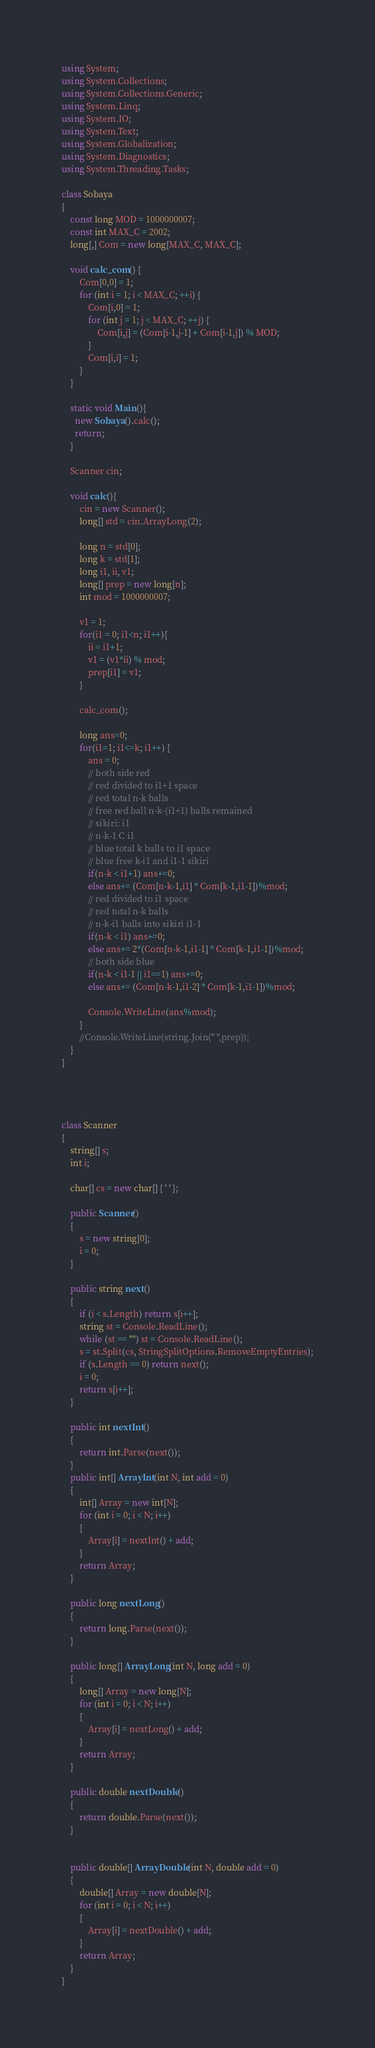Convert code to text. <code><loc_0><loc_0><loc_500><loc_500><_C#_>using System;
using System.Collections;
using System.Collections.Generic;
using System.Linq;
using System.IO;
using System.Text;
using System.Globalization;
using System.Diagnostics;
using System.Threading.Tasks;

class Sobaya
{
    const long MOD = 1000000007;
    const int MAX_C = 2002;
    long[,] Com = new long[MAX_C, MAX_C];
    
    void calc_com() {
        Com[0,0] = 1;
        for (int i = 1; i < MAX_C; ++i) {
            Com[i,0] = 1;
            for (int j = 1; j < MAX_C; ++j) {
                Com[i,j] = (Com[i-1,j-1] + Com[i-1,j]) % MOD;
            }
            Com[i,i] = 1;
        }
    }
    
    static void Main(){
      new Sobaya().calc();
      return;
    }
      
    Scanner cin;
    
    void calc(){
        cin = new Scanner();
        long[] std = cin.ArrayLong(2);
        
        long n = std[0];
        long k = std[1];
        long i1, ii, v1;
        long[] prep = new long[n];
        int mod = 1000000007;
        
        v1 = 1;
        for(i1 = 0; i1<n; i1++){
            ii = i1+1;
            v1 = (v1*ii) % mod;
            prep[i1] = v1;
        }
        
        calc_com();
        
        long ans=0;
        for(i1=1; i1<=k; i1++) {
            ans = 0;
            // both side red
            // red divided to i1+1 space
            // red total n-k balls
            // free red ball n-k-(i1+1) balls remained
            // sikiri: i1
            // n-k-1 C i1
            // blue total k balls to i1 space
            // blue free k-i1 and i1-1 sikiri
            if(n-k < i1+1) ans+=0;
            else ans+= (Com[n-k-1,i1] * Com[k-1,i1-1])%mod;
            // red divided to i1 space
            // red total n-k balls
            // n-k-i1 balls into sikiri i1-1
            if(n-k < i1) ans+=0;
            else ans+= 2*(Com[n-k-1,i1-1] * Com[k-1,i1-1])%mod;
            // both side blue
            if(n-k < i1-1 || i1==1) ans+=0;
            else ans+= (Com[n-k-1,i1-2] * Com[k-1,i1-1])%mod;
            
            Console.WriteLine(ans%mod);
        }
        //Console.WriteLine(string.Join(" ",prep));
    }
}




class Scanner
{
    string[] s;
    int i;
 
    char[] cs = new char[] { ' ' };
 
    public Scanner()
    {
        s = new string[0];
        i = 0;
    }
 
    public string next()
    {
        if (i < s.Length) return s[i++];
        string st = Console.ReadLine();
        while (st == "") st = Console.ReadLine();
        s = st.Split(cs, StringSplitOptions.RemoveEmptyEntries);
        if (s.Length == 0) return next();
        i = 0;
        return s[i++];
    }
 
    public int nextInt()
    {
        return int.Parse(next());
    }
    public int[] ArrayInt(int N, int add = 0)
    {
        int[] Array = new int[N];
        for (int i = 0; i < N; i++)
        {
            Array[i] = nextInt() + add;
        }
        return Array;
    }
 
    public long nextLong()
    {
        return long.Parse(next());
    }
 
    public long[] ArrayLong(int N, long add = 0)
    {
        long[] Array = new long[N];
        for (int i = 0; i < N; i++)
        {
            Array[i] = nextLong() + add;
        }
        return Array;
    }
 
    public double nextDouble()
    {
        return double.Parse(next());
    }
 
 
    public double[] ArrayDouble(int N, double add = 0)
    {
        double[] Array = new double[N];
        for (int i = 0; i < N; i++)
        {
            Array[i] = nextDouble() + add;
        }
        return Array;
    }
}
</code> 